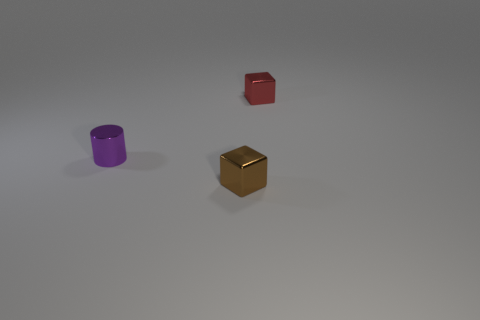What number of small objects are on the right side of the purple cylinder and in front of the red shiny block?
Make the answer very short. 1. There is a tiny brown thing; does it have the same shape as the tiny metal thing behind the tiny metal cylinder?
Offer a very short reply. Yes. Is the number of tiny brown metallic things right of the metallic cylinder greater than the number of big rubber spheres?
Provide a succinct answer. Yes. Is the number of brown shiny things that are behind the small purple shiny cylinder less than the number of tiny purple objects?
Your answer should be compact. Yes. What is the small object that is both in front of the tiny red metallic object and on the right side of the tiny purple thing made of?
Provide a succinct answer. Metal. There is a small cube in front of the shiny cylinder; is it the same color as the thing that is left of the brown metallic thing?
Ensure brevity in your answer.  No. How many purple objects are either metallic spheres or metal cylinders?
Provide a short and direct response. 1. Is the number of tiny red metallic blocks on the left side of the small cylinder less than the number of small brown metal objects in front of the red shiny cube?
Keep it short and to the point. Yes. Is there a red metallic thing that has the same size as the purple cylinder?
Provide a short and direct response. Yes. Do the block behind the brown metallic block and the brown metal cube have the same size?
Provide a short and direct response. Yes. 